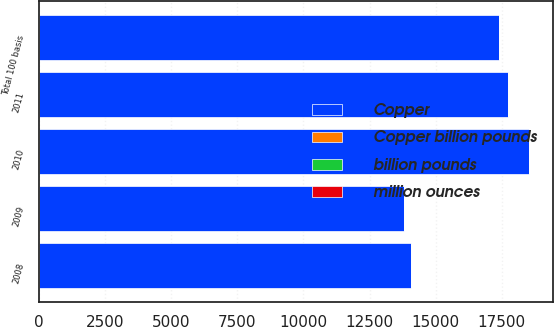<chart> <loc_0><loc_0><loc_500><loc_500><stacked_bar_chart><ecel><fcel>2008<fcel>2009<fcel>2010<fcel>2011<fcel>Total 100 basis<nl><fcel>Copper<fcel>14067<fcel>13807<fcel>18516<fcel>17739<fcel>17394<nl><fcel>million ounces<fcel>0.48<fcel>0.49<fcel>0.42<fcel>0.43<fcel>0.43<nl><fcel>billion pounds<fcel>0.17<fcel>0.17<fcel>0.12<fcel>0.12<fcel>0.12<nl><fcel>Copper billion pounds<fcel>0.01<fcel>0.01<fcel>0.01<fcel>0.01<fcel>0.01<nl></chart> 